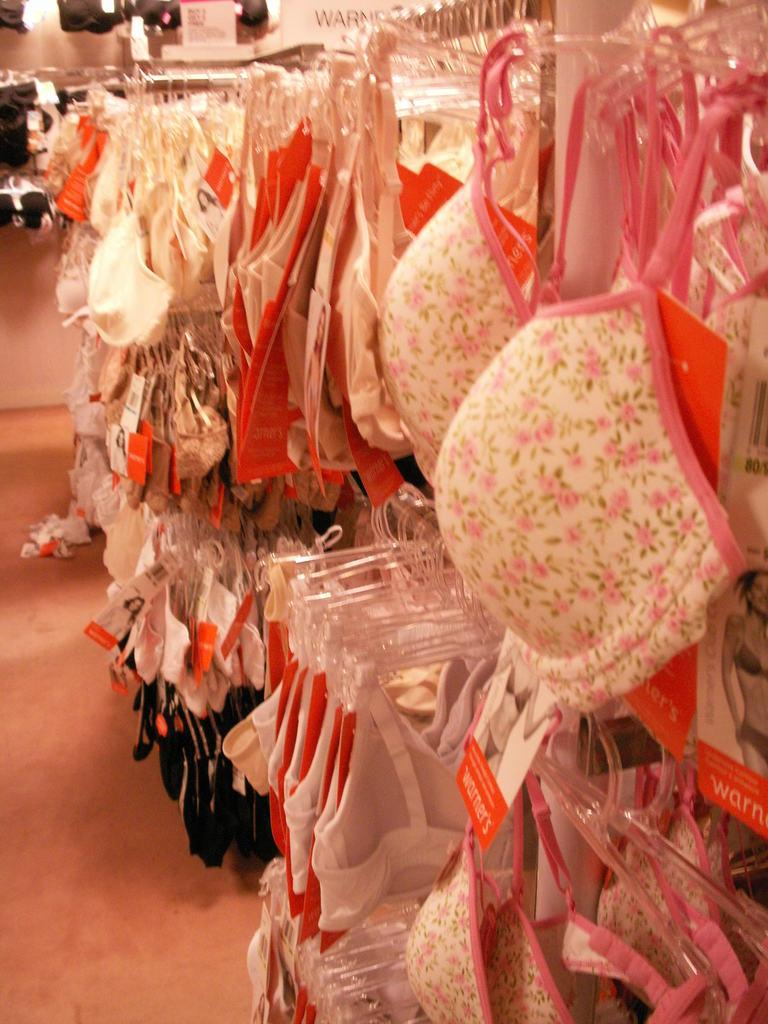What objects are present on the clothes hangers in the image? Clothes are hanged on cloth hangers in the image. How are the clothes arranged on the hangers? The clothes are hung neatly on the hangers. What might be the purpose of hanging clothes on hangers? The purpose of hanging clothes on hangers could be for storage, organization, or drying. How many mice can be seen running around the clothes in the image? There are no mice present in the image; it only shows clothes on hangers. 